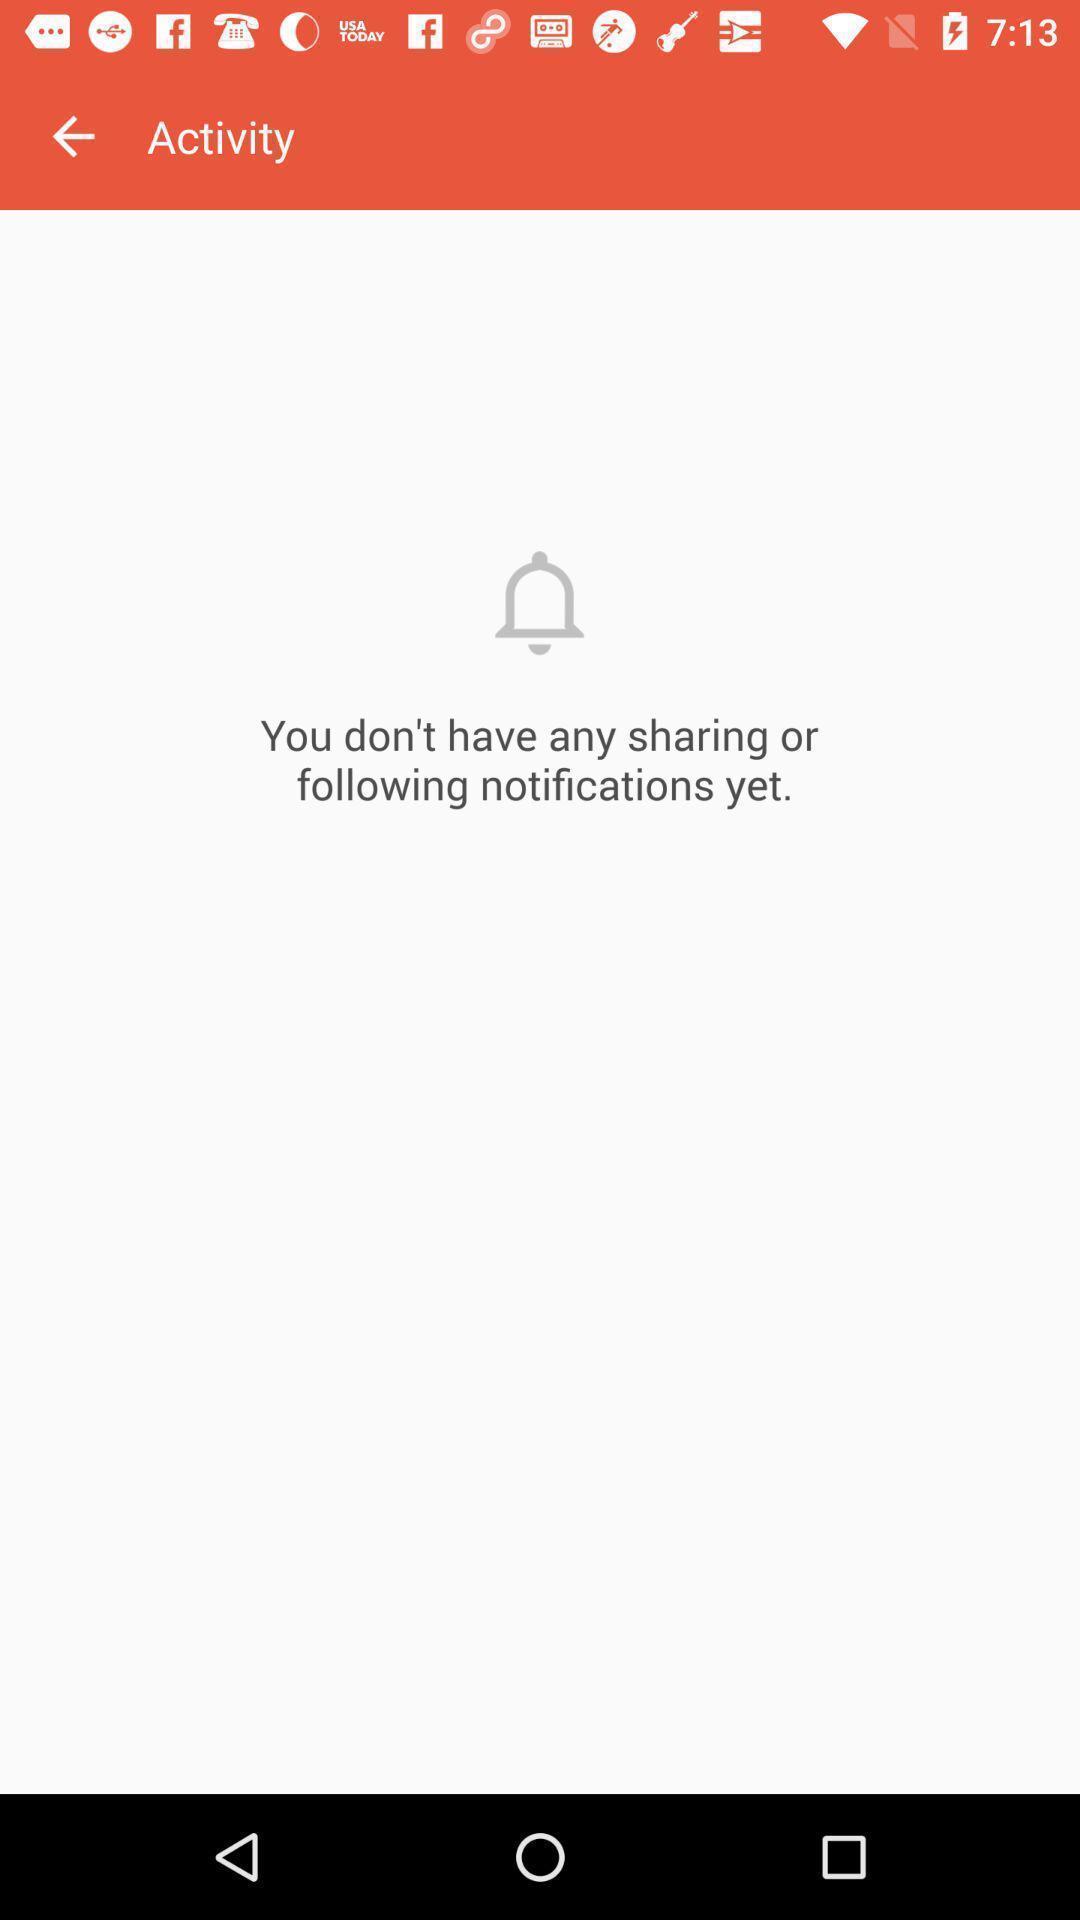Describe the key features of this screenshot. Screen displaying notification message contents in activity page. 